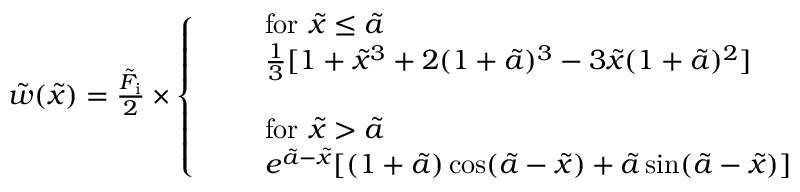Convert formula to latex. <formula><loc_0><loc_0><loc_500><loc_500>\begin{array} { r } { \tilde { w } ( \tilde { x } ) = \frac { \tilde { F } _ { i } } { 2 } \times \left \{ \begin{array} { l l } & { f o r \tilde { x } \leq \tilde { a } } \\ & { \frac { 1 } { 3 } [ 1 + \tilde { x } ^ { 3 } + 2 ( 1 + \tilde { a } ) ^ { 3 } - 3 \tilde { x } ( 1 + \tilde { a } ) ^ { 2 } ] } \\ { \quad } \\ & { f o r \tilde { x } > \tilde { a } } \\ & { e ^ { \tilde { a } - \tilde { x } } [ ( 1 + \tilde { a } ) \cos ( \tilde { a } - \tilde { x } ) + \tilde { a } \sin ( \tilde { a } - \tilde { x } ) ] } \end{array} } \end{array}</formula> 